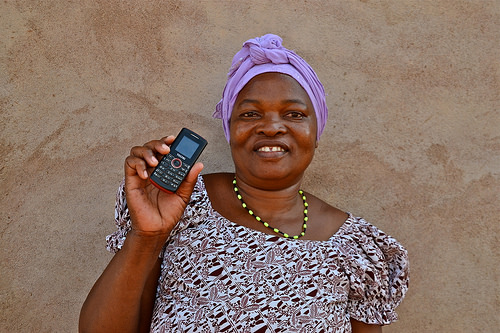<image>
Is the phone to the left of the head wrap? Yes. From this viewpoint, the phone is positioned to the left side relative to the head wrap. 